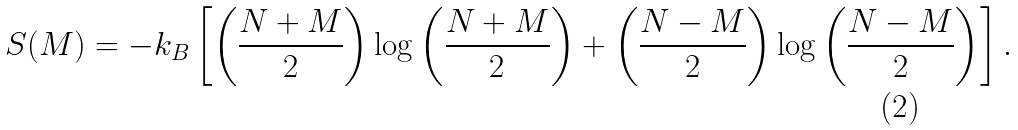<formula> <loc_0><loc_0><loc_500><loc_500>S ( M ) = - k _ { B } \left [ \left ( \frac { N + M } { 2 } \right ) \log \left ( \frac { N + M } { 2 } \right ) + \left ( \frac { N - M } { 2 } \right ) \log \left ( \frac { N - M } { 2 } \right ) \right ] .</formula> 